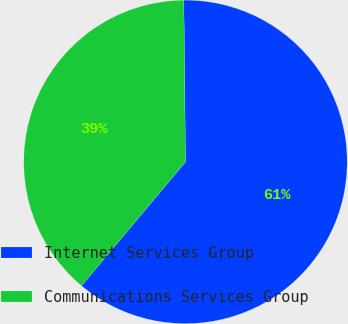Convert chart. <chart><loc_0><loc_0><loc_500><loc_500><pie_chart><fcel>Internet Services Group<fcel>Communications Services Group<nl><fcel>61.28%<fcel>38.72%<nl></chart> 